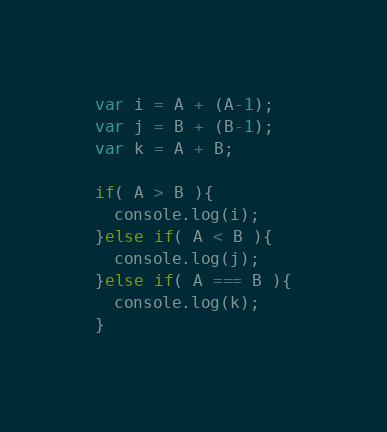<code> <loc_0><loc_0><loc_500><loc_500><_JavaScript_>var i = A + (A-1);
var j = B + (B-1);
var k = A + B;
 
if( A > B ){
  console.log(i);
}else if( A < B ){
  console.log(j);
}else if( A === B ){
  console.log(k);
}</code> 